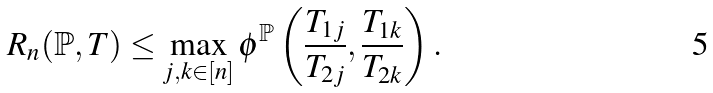<formula> <loc_0><loc_0><loc_500><loc_500>R _ { n } ( \mathbb { P } , T ) \leq \max _ { j , k \in [ n ] } \phi ^ { \mathbb { P } } \left ( \frac { T _ { 1 j } } { T _ { 2 j } } , \frac { T _ { 1 k } } { T _ { 2 k } } \right ) .</formula> 